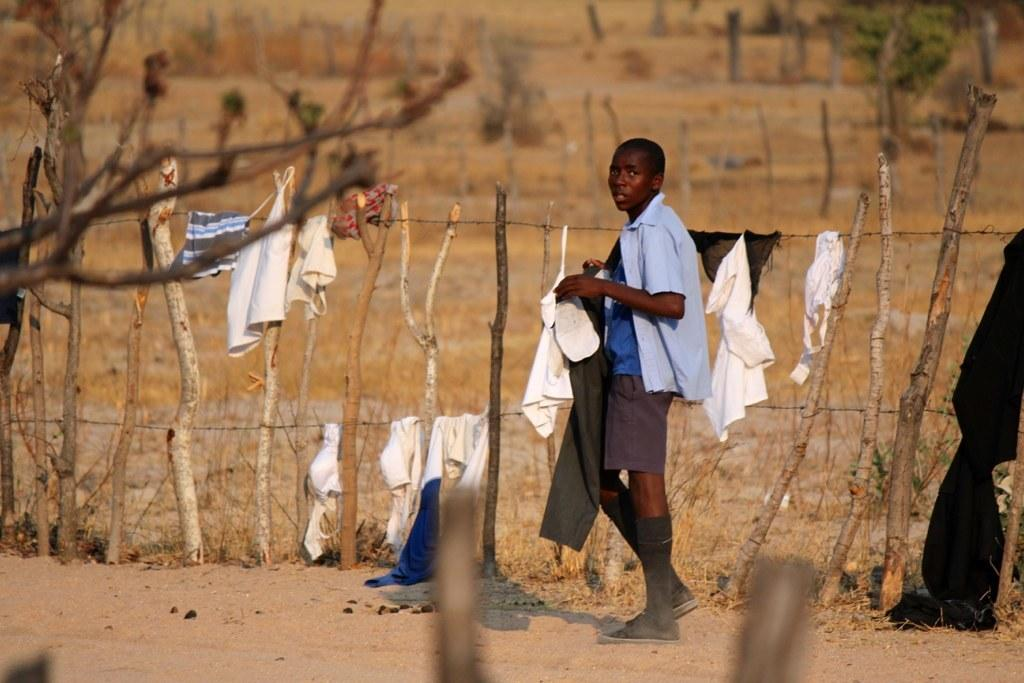Who is the main subject in the image? There is a boy in the image. What is the boy holding in his hand? The boy is holding a pant in his hand. What is the boy doing in the image? The boy is walking on the ground. What else can be seen in the image besides the boy? There are sticks visible in the image, and clothes are hanging on a fence. What is visible in the background of the image? There are trees in the background of the image. What type of turkey is being prepared for the feast in the image? There is no turkey or feast present in the image; it features a boy holding a pant and walking on the ground. 